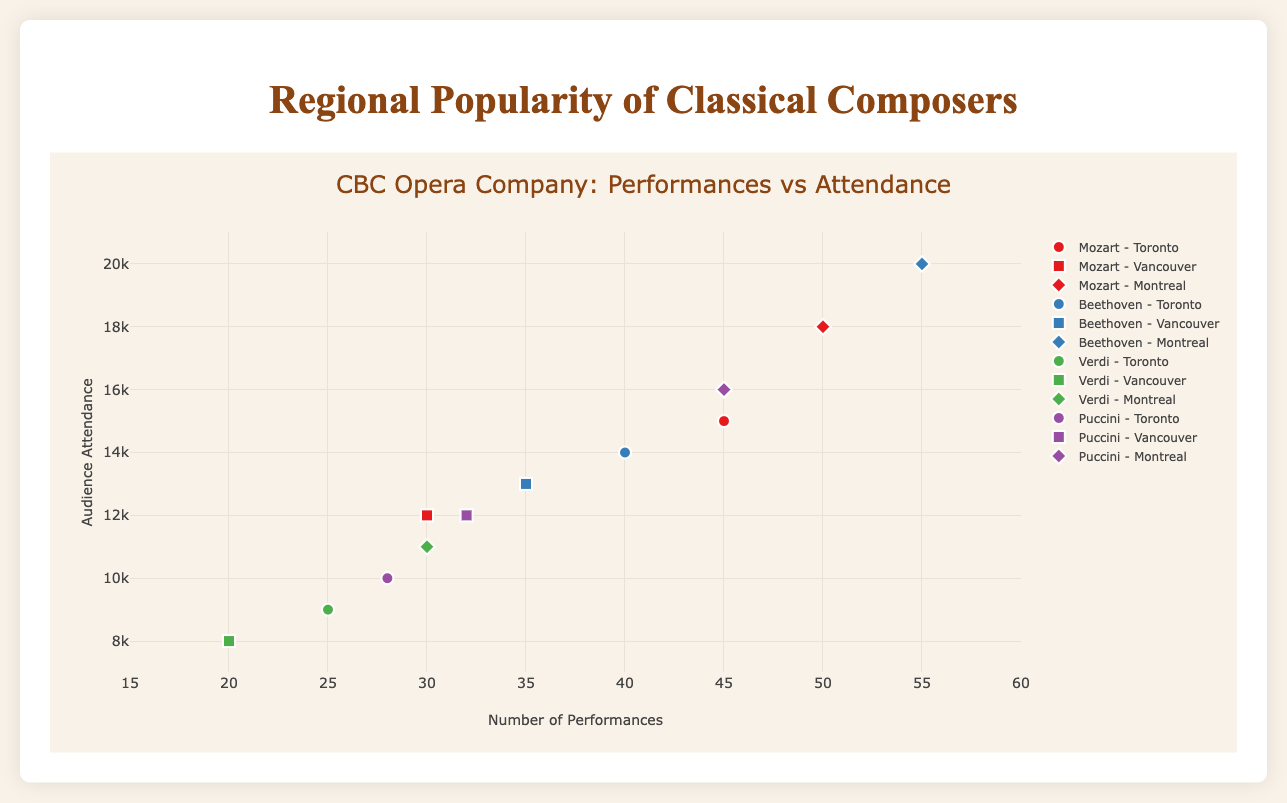What is the title of the figure? The title can be seen at the top of the figure. It reads: "CBC Opera Company: Performances vs Attendance".
Answer: CBC Opera Company: Performances vs Attendance Which region had the highest audience attendance for Mozart? Check the markers labeled "Mozart" and identify the highest point on the y-axis for each region. Montreal shows the highest attendance of 18,000.
Answer: Montreal How many performances did Beethoven have in Vancouver? Look for the marker labeled "Beethoven - Vancouver" and check the x-axis value. It shows 35 performances.
Answer: 35 What color represents Puccini in the plot? Observe the color-coded markers for Puccini. The color representing Puccini is #984ea3 (purple).
Answer: Purple Compare Mozart's and Beethoven's audience attendance in Toronto. Who had more, and by how much? Compare the y-axis values for Mozart and Beethoven in Toronto. Mozart had 15,000 attendees and Beethoven had 14,000. Subtract Beethoven's attendance from Mozart’s: 15,000 - 14,000.
Answer: Mozart, 1,000 more Calculate the average performances for each composer across all regions. Sum the performances for each composer in Toronto, Vancouver, and Montreal, then divide by the number of regions (3):
Mozart: (45 + 30 + 50) / 3 = 125 / 3 = 41.67
Beethoven: (40 + 35 + 55) / 3 = 130 / 3 = 43.33
Verdi: (25 + 20 + 30) / 3 = 75 / 3 = 25
Puccini: (28 + 32 + 45) / 3 = 105 / 3 = 35
Answer: Mozart: 41.67, Beethoven: 43.33, Verdi: 25, Puccini: 35 Which composer had the highest number of performances in any region? Find the maximum x-axis value for each composer across all regions. Beethoven in Montreal has the highest with 55 performances.
Answer: Beethoven Among the regions, which one had the lowest audience attendance for Verdi? Check the y-axis values for Verdi's markers. Vancouver had the lowest attendance with 8,000 attendees.
Answer: Vancouver 